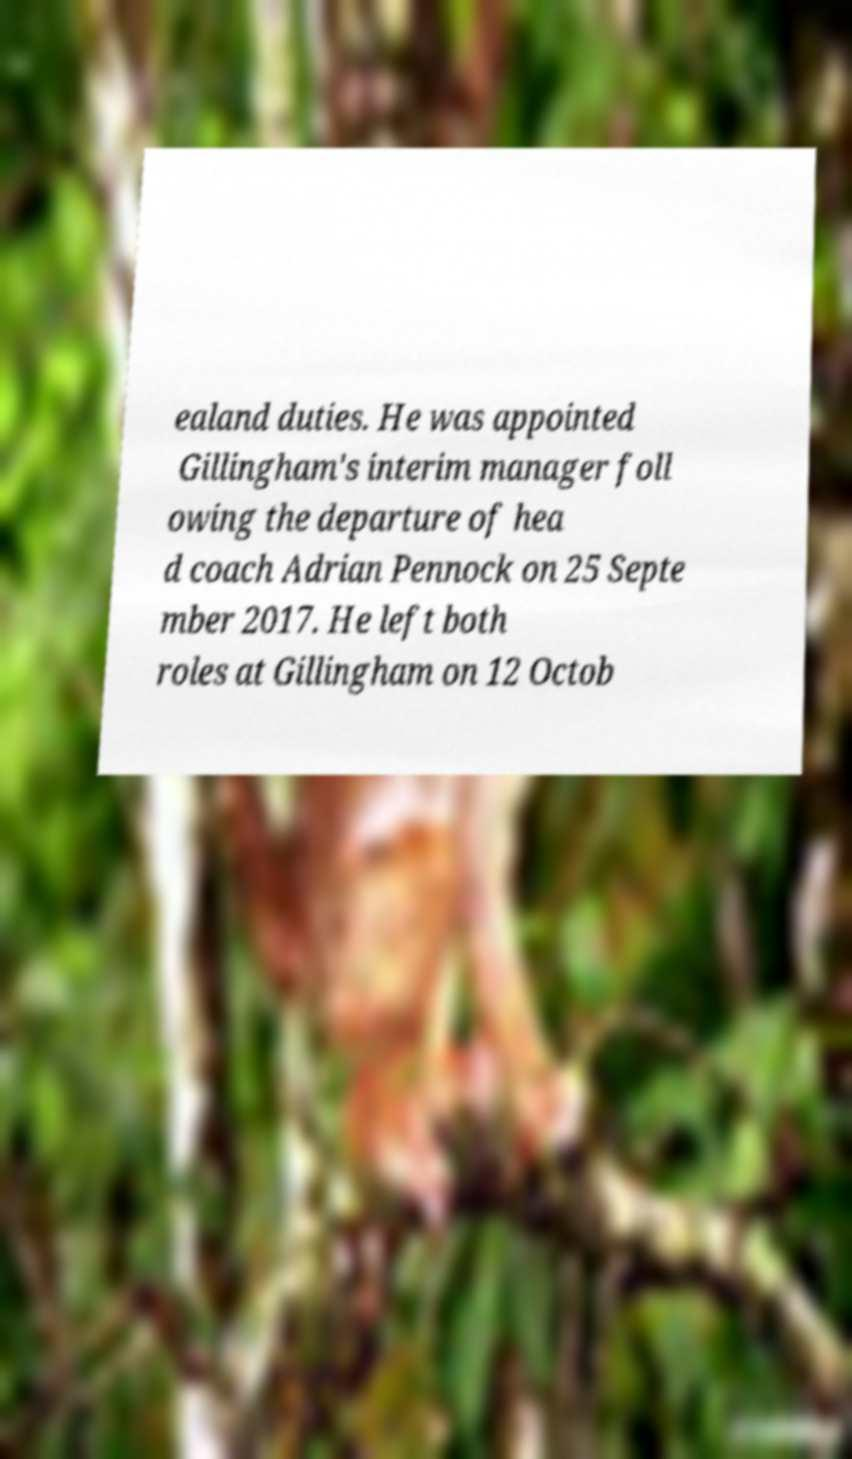There's text embedded in this image that I need extracted. Can you transcribe it verbatim? ealand duties. He was appointed Gillingham's interim manager foll owing the departure of hea d coach Adrian Pennock on 25 Septe mber 2017. He left both roles at Gillingham on 12 Octob 